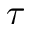Convert formula to latex. <formula><loc_0><loc_0><loc_500><loc_500>\tau</formula> 